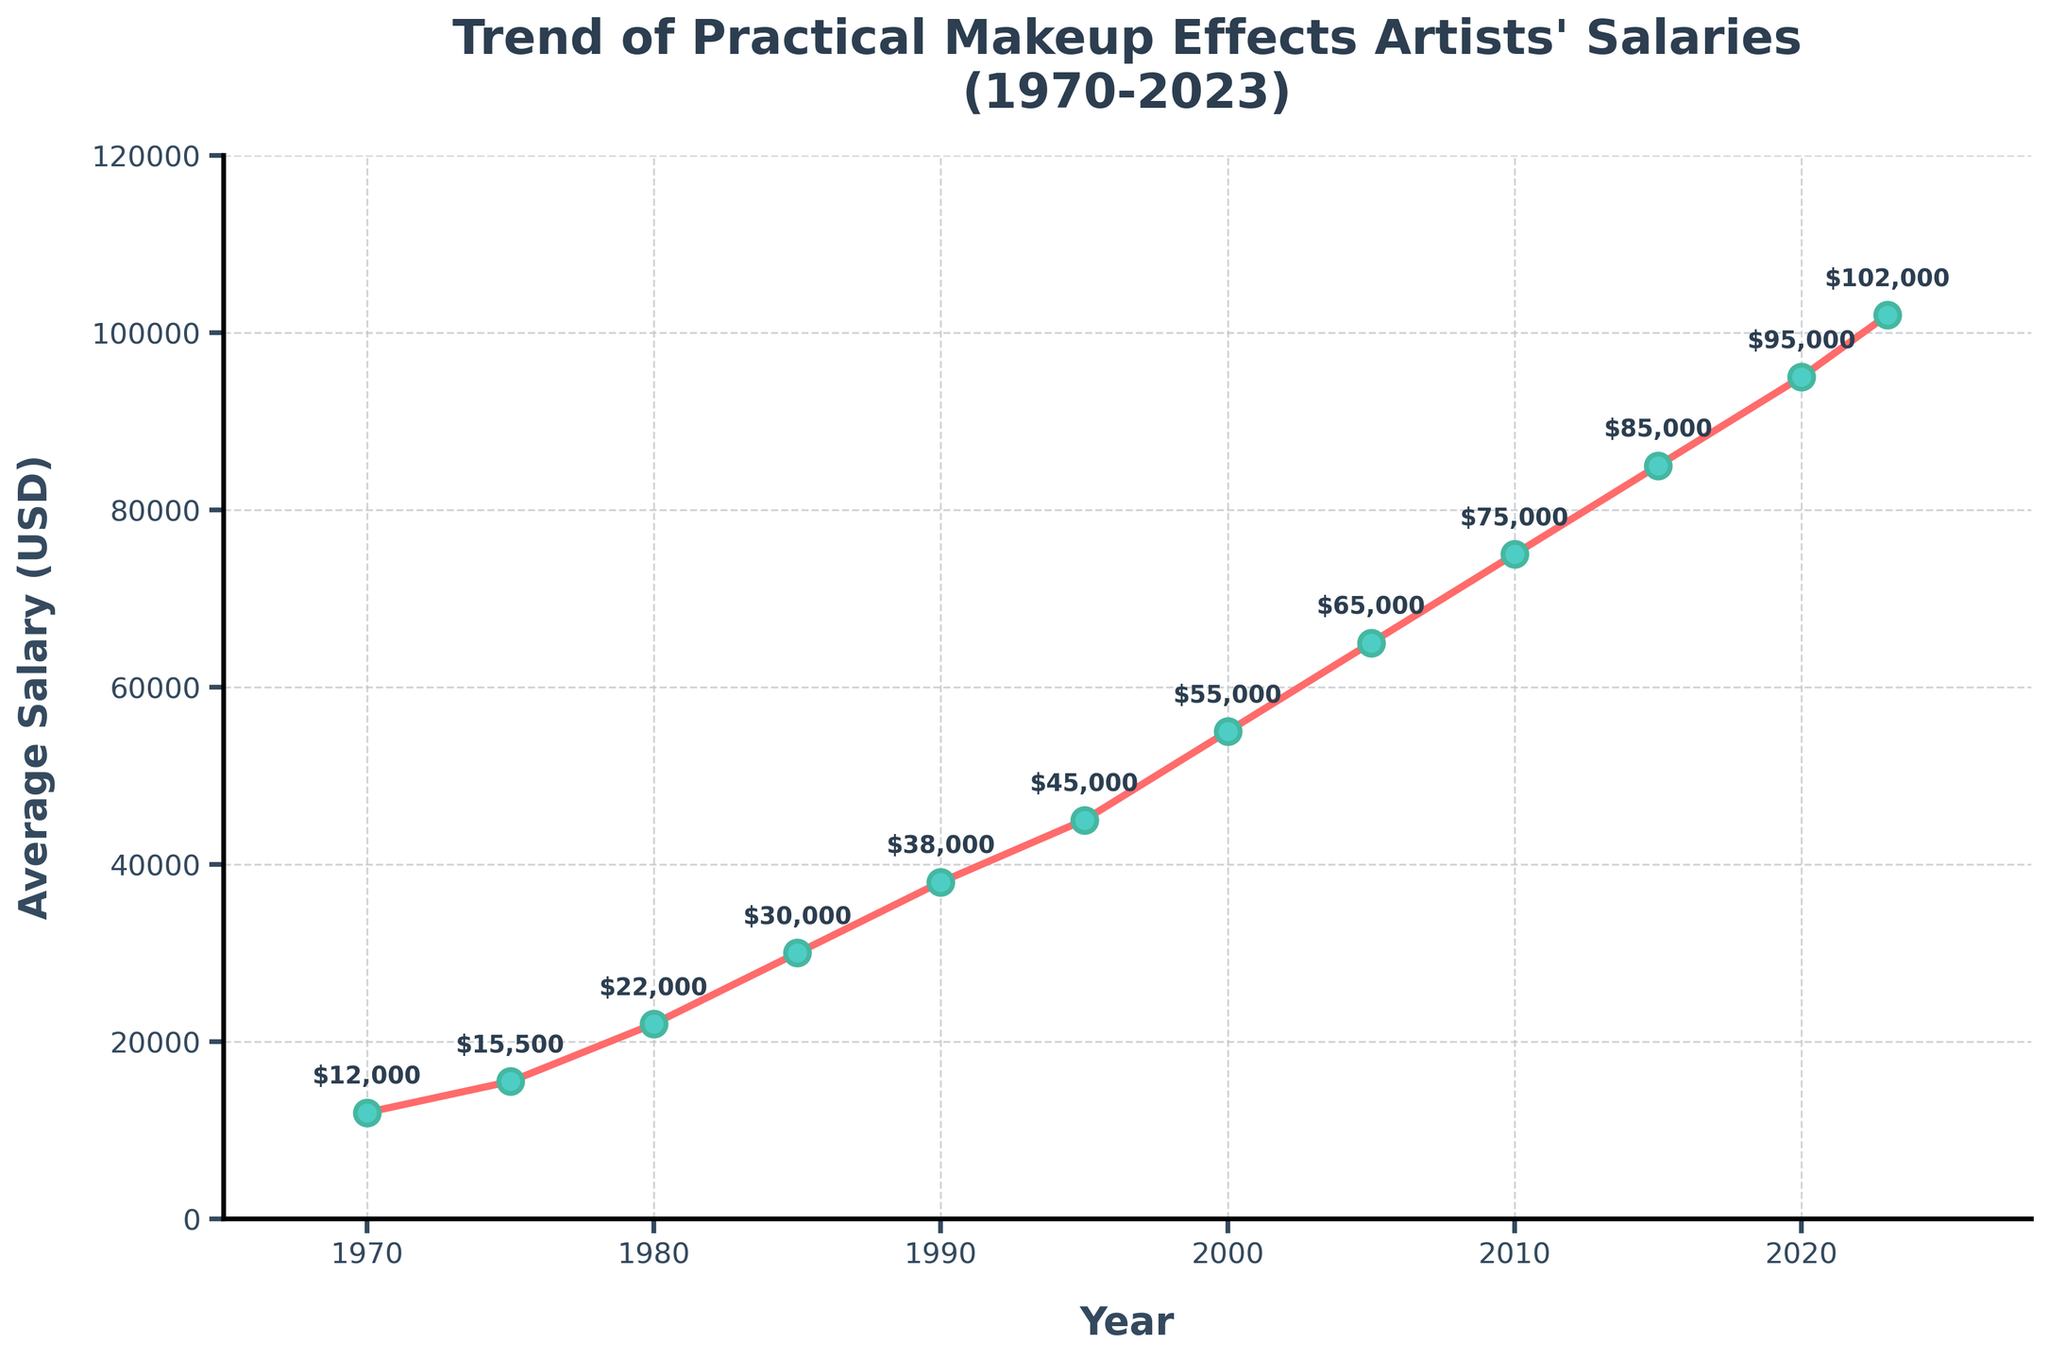What's the average salary increase per decade from 1970 to 2020? To find the average salary increase per decade, calculate the salary difference between each plotted decade and then average these differences. (2020-2010)=$20000, (2010-2000)=$20000, (2000-1990)=$17000, (1990-1980)=$16000, (1980-1970)=$10000. Average increase per decade = ($20000 + $20000 + $17000 + $16000 + $10000) / 5 = $16600
Answer: $16600 During which decade did practical makeup effects artists experience the largest increase in average salary? Look at the differences between the salaries for each decade: (1970-1980)=$10000, (1980-1990)=$16000, (1990-2000)=$17000, (2000-2010)=$20000, (2010-2020)=$20000. The largest increase is from 2000 to 2010 and 2010 to 2020 ($20000 each).
Answer: 2000-2010 and 2010-2020 How much did the average salary of practical makeup effects artists change from 1970 to 2023? Subtract the 1970 salary from the 2023 salary: $102000 - $12000 = $90000
Answer: $90000 What is the total difference in average salary from 1985 to 2023? Subtract the 1985 salary from the 2023 salary: $102000 - $30000 = $72000
Answer: $72000 Compare the average salary of practical makeup effects artists in 1980 and 2000. By how much did it increase? Subtract the 1980 salary from the 2000 salary: $55000 - $22000 = $33000
Answer: $33000 Which year marks the first time the average salary of practical makeup effects artists crossed $50,000? Look at the data points and find the first year salary exceeds $50000. In 2000, the salary is $55000.
Answer: 2000 Visually, which year had the most significant upward annotation pointing from the salary line? The most significant upward annotation in terms of visual height difference is seen between 2010 ($75000) and 2015 ($85000).
Answer: 2015 What was the average salary in the mid-1990s? The mid-1990s is approximately 1995. The average salary in 1995 was $45000.
Answer: $45000 If the trend continues, what would be a rough estimate for the average salary in 2025? Using the recent trend from 2015 to 2023, calculate the annual average increase: ($102000 - $85000)/(2023-2015) = $17000/8 ≈ $2125 per year. From 2023 to 2025, (2 years * $2125) = $4250 increase. Adding that to 2023's salary: $102000 + $4250 = $106250
Answer: $106250 